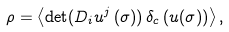Convert formula to latex. <formula><loc_0><loc_0><loc_500><loc_500>\rho = \left < \det ( D _ { i } u ^ { j } \left ( \sigma ) \right ) \delta _ { c } \left ( u ( \sigma ) \right ) \right > ,</formula> 